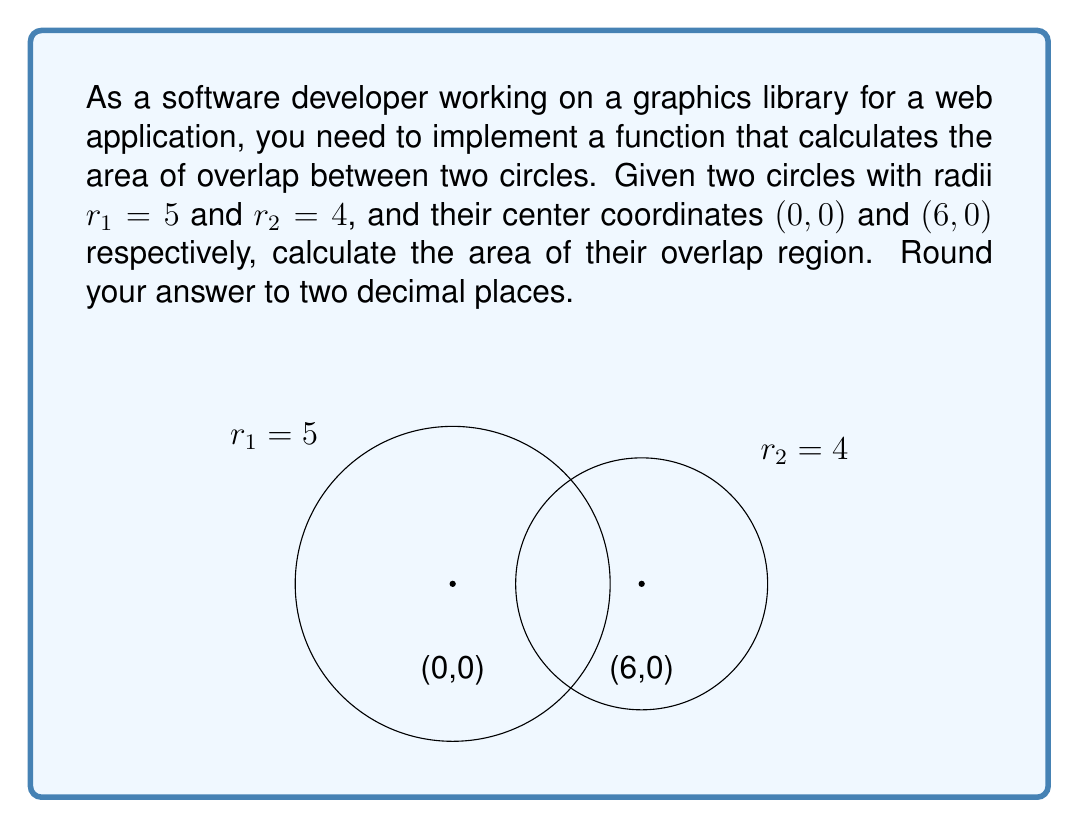Give your solution to this math problem. To solve this problem, we'll follow these steps:

1) First, calculate the distance $d$ between the centers of the circles using the distance formula:
   $$d = \sqrt{(x_2 - x_1)^2 + (y_2 - y_1)^2} = \sqrt{(6 - 0)^2 + (0 - 0)^2} = 6$$

2) The circles overlap, so we can use the formula for the area of intersection:
   $$A = r_1^2 \arccos(\frac{d^2 + r_1^2 - r_2^2}{2dr_1}) + r_2^2 \arccos(\frac{d^2 + r_2^2 - r_1^2}{2dr_2}) - \frac{1}{2}\sqrt{(-d+r_1+r_2)(d+r_1-r_2)(d-r_1+r_2)(d+r_1+r_2)}$$

3) Substitute the values:
   $$A = 5^2 \arccos(\frac{6^2 + 5^2 - 4^2}{2 \cdot 6 \cdot 5}) + 4^2 \arccos(\frac{6^2 + 4^2 - 5^2}{2 \cdot 6 \cdot 4}) - \frac{1}{2}\sqrt{(-6+5+4)(6+5-4)(6-5+4)(6+5+4)}$$

4) Simplify:
   $$A = 25 \arccos(\frac{61}{60}) + 16 \arccos(\frac{52}{48}) - \frac{1}{2}\sqrt{3 \cdot 7 \cdot 5 \cdot 15}$$

5) Calculate:
   $$A \approx 25 \cdot 0.8740 + 16 \cdot 1.0472 - \frac{1}{2} \cdot 14.3178 \approx 21.8507 + 16.7552 - 7.1589 \approx 31.4470$$

6) Round to two decimal places: 31.45
Answer: 31.45 square units 